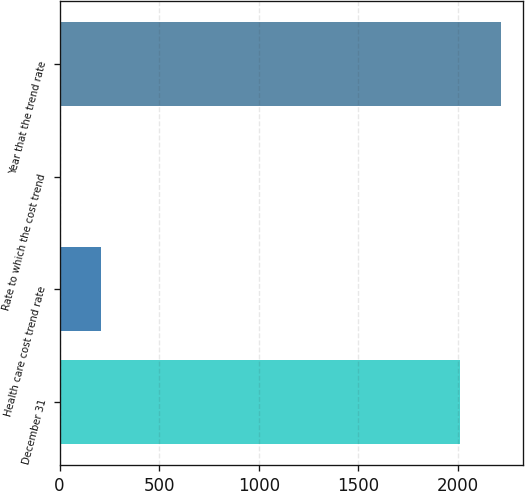Convert chart. <chart><loc_0><loc_0><loc_500><loc_500><bar_chart><fcel>December 31<fcel>Health care cost trend rate<fcel>Rate to which the cost trend<fcel>Year that the trend rate<nl><fcel>2013<fcel>206.84<fcel>4.6<fcel>2215.24<nl></chart> 